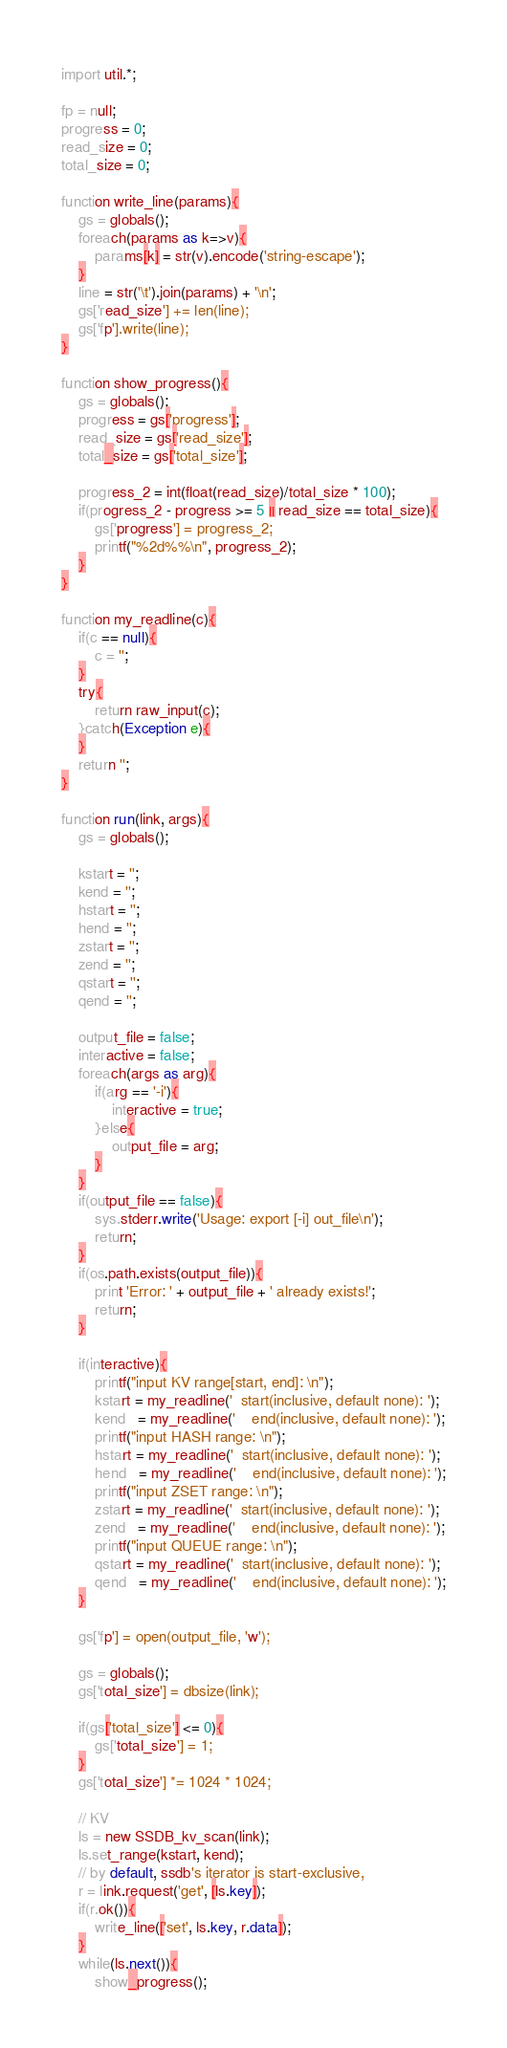<code> <loc_0><loc_0><loc_500><loc_500><_COBOL_>import util.*;

fp = null;
progress = 0;
read_size = 0;
total_size = 0;

function write_line(params){
	gs = globals();
	foreach(params as k=>v){
		params[k] = str(v).encode('string-escape');
	}
	line = str('\t').join(params) + '\n';
	gs['read_size'] += len(line);
	gs['fp'].write(line);
}

function show_progress(){
	gs = globals();
	progress = gs['progress'];
	read_size = gs['read_size'];
	total_size = gs['total_size'];

	progress_2 = int(float(read_size)/total_size * 100);
	if(progress_2 - progress >= 5 || read_size == total_size){
		gs['progress'] = progress_2;
		printf("%2d%%\n", progress_2);
	}
}

function my_readline(c){
	if(c == null){
		c = '';
	}
	try{
		return raw_input(c);
	}catch(Exception e){
	}
	return '';
}

function run(link, args){
	gs = globals();

	kstart = '';
	kend = '';
	hstart = '';
	hend = '';
	zstart = '';
	zend = '';
	qstart = '';
	qend = '';

	output_file = false;
	interactive = false;
	foreach(args as arg){
		if(arg == '-i'){
			interactive = true;
		}else{
			output_file = arg;
		}
	}
	if(output_file == false){
		sys.stderr.write('Usage: export [-i] out_file\n');
		return;
	}
	if(os.path.exists(output_file)){
		print 'Error: ' + output_file + ' already exists!';
		return;
	}

	if(interactive){
		printf("input KV range[start, end]: \n");
		kstart = my_readline('  start(inclusive, default none): ');
		kend   = my_readline('    end(inclusive, default none): ');
		printf("input HASH range: \n");
		hstart = my_readline('  start(inclusive, default none): ');
		hend   = my_readline('    end(inclusive, default none): ');
		printf("input ZSET range: \n");
		zstart = my_readline('  start(inclusive, default none): ');
		zend   = my_readline('    end(inclusive, default none): ');
		printf("input QUEUE range: \n");
		qstart = my_readline('  start(inclusive, default none): ');
		qend   = my_readline('    end(inclusive, default none): ');
	}
	
	gs['fp'] = open(output_file, 'w');
	
	gs = globals();
	gs['total_size'] = dbsize(link);

	if(gs['total_size'] <= 0){
		gs['total_size'] = 1;
	}
	gs['total_size'] *= 1024 * 1024;

	// KV
	ls = new SSDB_kv_scan(link);
	ls.set_range(kstart, kend);
	// by default, ssdb's iterator is start-exclusive,
	r = link.request('get', [ls.key]);
	if(r.ok()){
		write_line(['set', ls.key, r.data]);
	}
	while(ls.next()){
		show_progress();</code> 